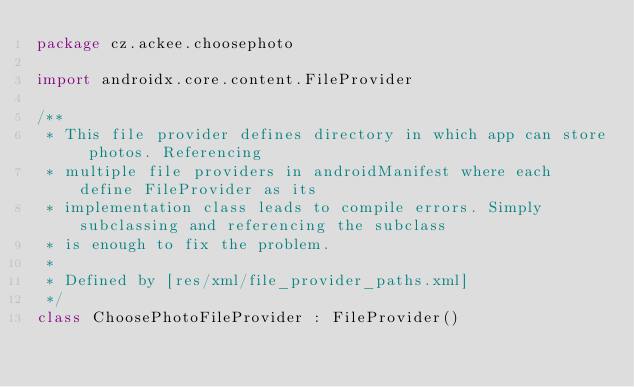<code> <loc_0><loc_0><loc_500><loc_500><_Kotlin_>package cz.ackee.choosephoto

import androidx.core.content.FileProvider

/**
 * This file provider defines directory in which app can store photos. Referencing
 * multiple file providers in androidManifest where each define FileProvider as its
 * implementation class leads to compile errors. Simply subclassing and referencing the subclass
 * is enough to fix the problem.
 *
 * Defined by [res/xml/file_provider_paths.xml]
 */
class ChoosePhotoFileProvider : FileProvider()</code> 